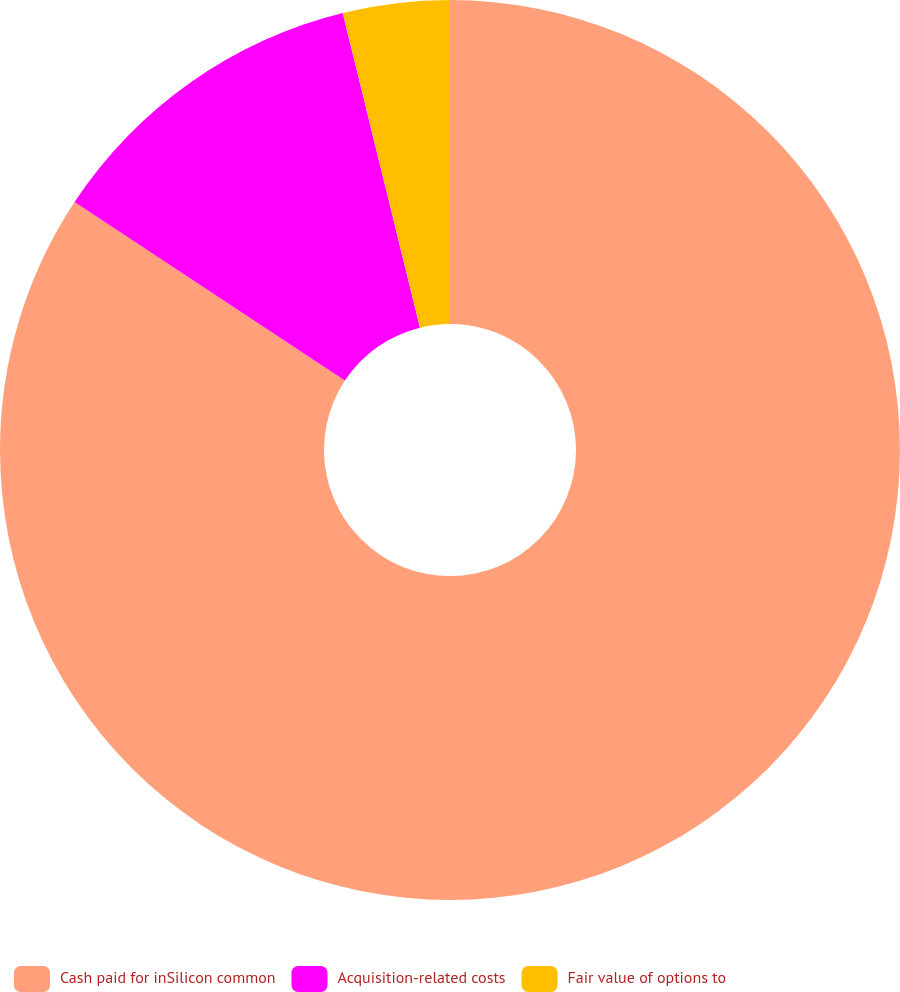<chart> <loc_0><loc_0><loc_500><loc_500><pie_chart><fcel>Cash paid for inSilicon common<fcel>Acquisition-related costs<fcel>Fair value of options to<nl><fcel>84.29%<fcel>11.88%<fcel>3.83%<nl></chart> 